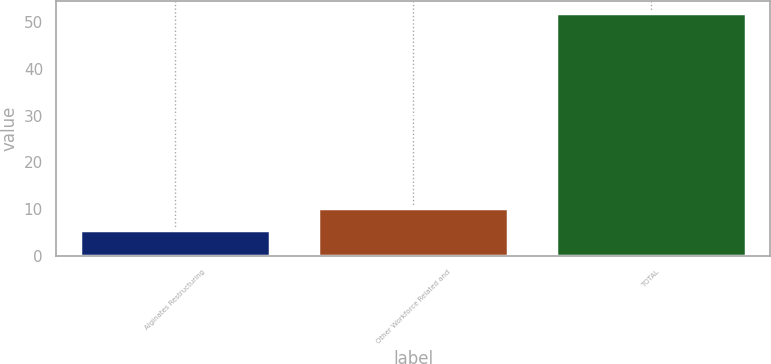Convert chart to OTSL. <chart><loc_0><loc_0><loc_500><loc_500><bar_chart><fcel>Alginates Restructuring<fcel>Other Workforce Related and<fcel>TOTAL<nl><fcel>5.6<fcel>10.24<fcel>52<nl></chart> 